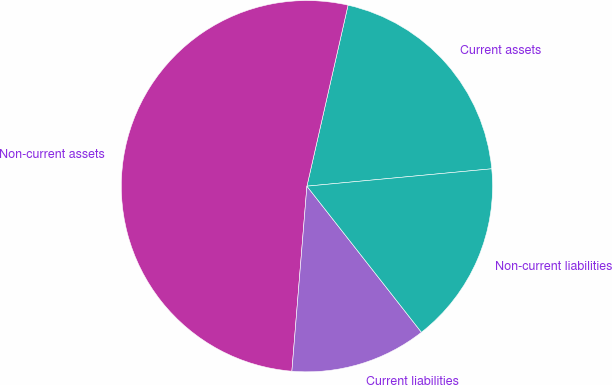<chart> <loc_0><loc_0><loc_500><loc_500><pie_chart><fcel>Current assets<fcel>Non-current assets<fcel>Current liabilities<fcel>Non-current liabilities<nl><fcel>19.95%<fcel>52.26%<fcel>11.87%<fcel>15.91%<nl></chart> 